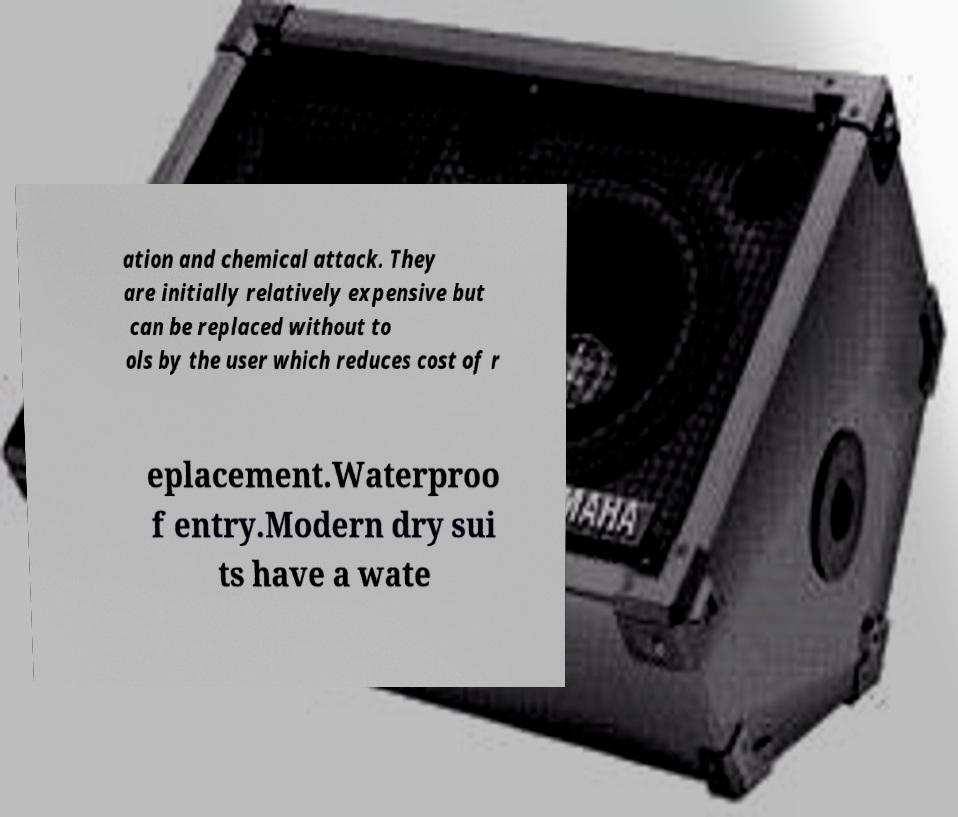Can you read and provide the text displayed in the image?This photo seems to have some interesting text. Can you extract and type it out for me? ation and chemical attack. They are initially relatively expensive but can be replaced without to ols by the user which reduces cost of r eplacement.Waterproo f entry.Modern dry sui ts have a wate 